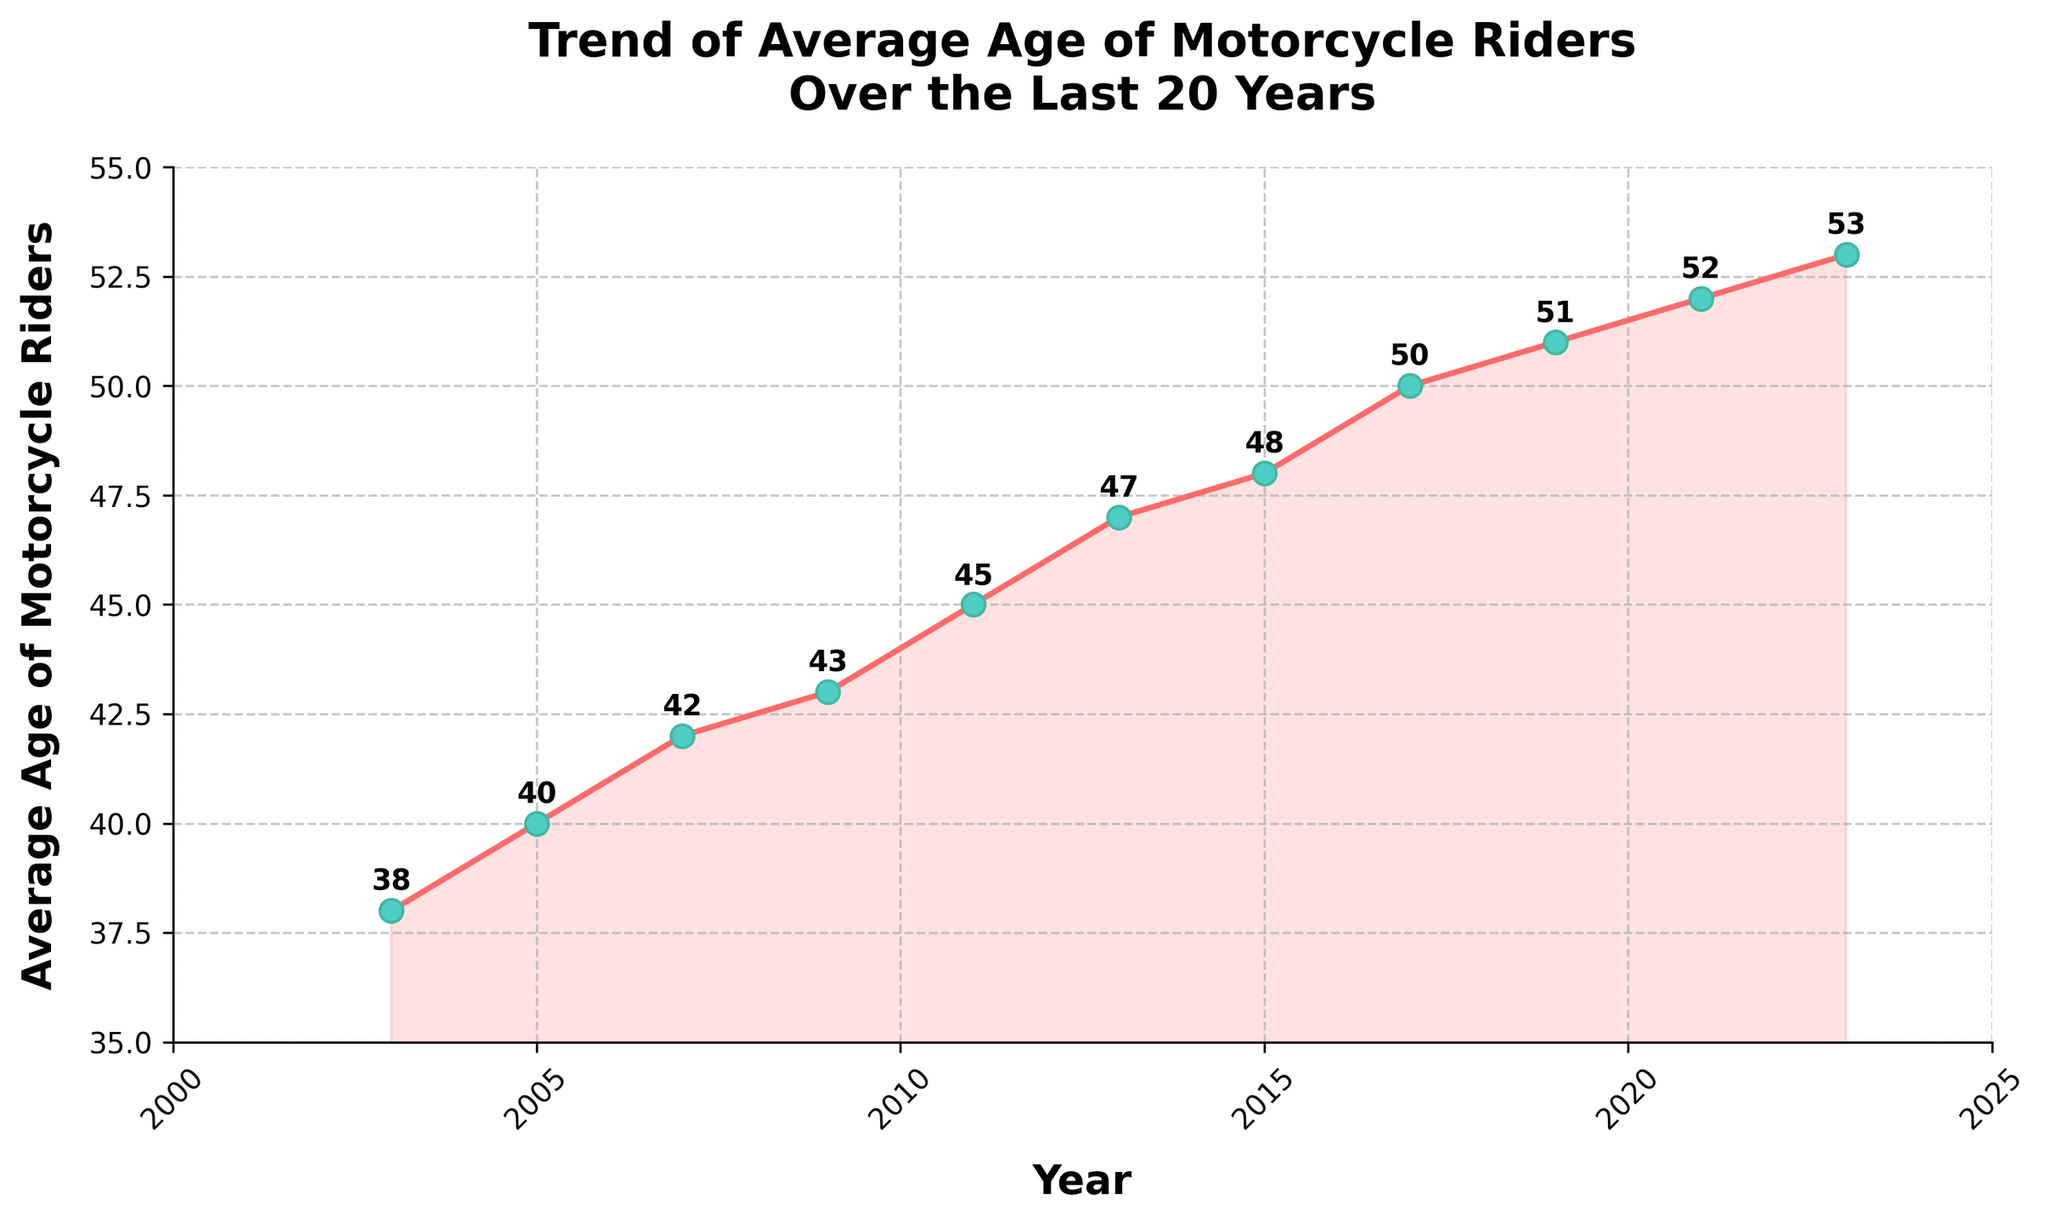What was the average age of motorcycle riders in 2009? The figure shows data points plotted for each year, and the label on the data point corresponding to 2009 indicates the average age.
Answer: 43 Has the average age of motorcycle riders increased or decreased over the last 20 years? By observing the trend line from 2003 to 2023, it is clear that the average age has increased as the line goes upward.
Answer: Increased By how much has the average age of motorcycle riders changed from 2003 to 2023? The average age in 2003 was 38 and in 2023 it was 53. The difference is calculated as 53 - 38 = 15.
Answer: 15 During which period did the average age of motorcycle riders increase the most? By comparing the rise between consecutive data points, the period with the largest increase is between 2019 (51) to 2021 (52), a rise of 1 year.
Answer: 2019-2021 What is the average average age of motorcycle riders over the 20-year period? To find the average of the average ages, add the ages from each year and divide by the number of years: (38+40+42+43+45+47+48+50+51+52+53)/11 ≈ 46.
Answer: 46 Is there any year where the average age remained the same as the previous year? By examining the plotted data points and labels, every year shows an increase in age with no repeated values, indicating that there were no years with unchanged average age.
Answer: No Which year had the highest average age of motorcycle riders? The highest data point on the chart corresponds to the year 2023, with an average age of 53.
Answer: 2023 How does the trend from 2011 to 2013 compare to the trend from 2017 to 2019? From 2011 (45) to 2013 (47) the age increased by 2 years, while from 2017 (50) to 2019 (51) the age increased by 1 year. Thus, the increase from 2011 to 2013 was larger.
Answer: 2011-2013 had a larger increase Has the rate of increase in the average age of motorcycle riders been constant over the years? By observing the overall trend, it appears that there are varies in the slope, indicating that the rate of increase has not been constant.
Answer: No 